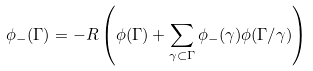<formula> <loc_0><loc_0><loc_500><loc_500>\phi _ { - } ( \Gamma ) = - R \left ( \phi ( \Gamma ) + \sum _ { \gamma \subset \Gamma } \phi _ { - } ( \gamma ) \phi ( \Gamma / \gamma ) \right )</formula> 